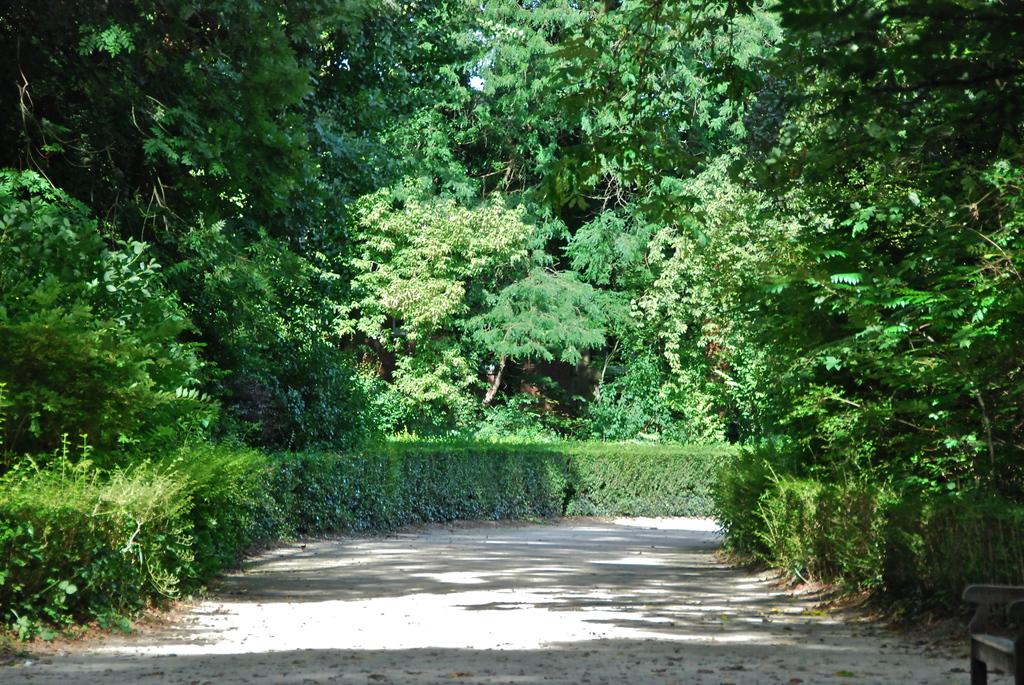What type of pathway is visible in the image? There is a road in the image. What natural elements can be seen in the image? There are trees and bushes in the image. Can you describe the object in the bottom right corner of the image? There appears to be a chair in the bottom right corner of the image. Is it raining in the image? There is no indication of rain in the image. Can you tell me what the people in the image are talking about? There are no people visible in the image. 